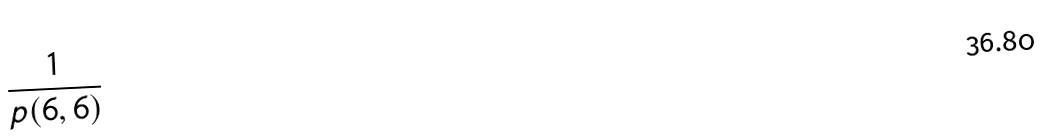Convert formula to latex. <formula><loc_0><loc_0><loc_500><loc_500>\frac { 1 } { p ( 6 , 6 ) }</formula> 